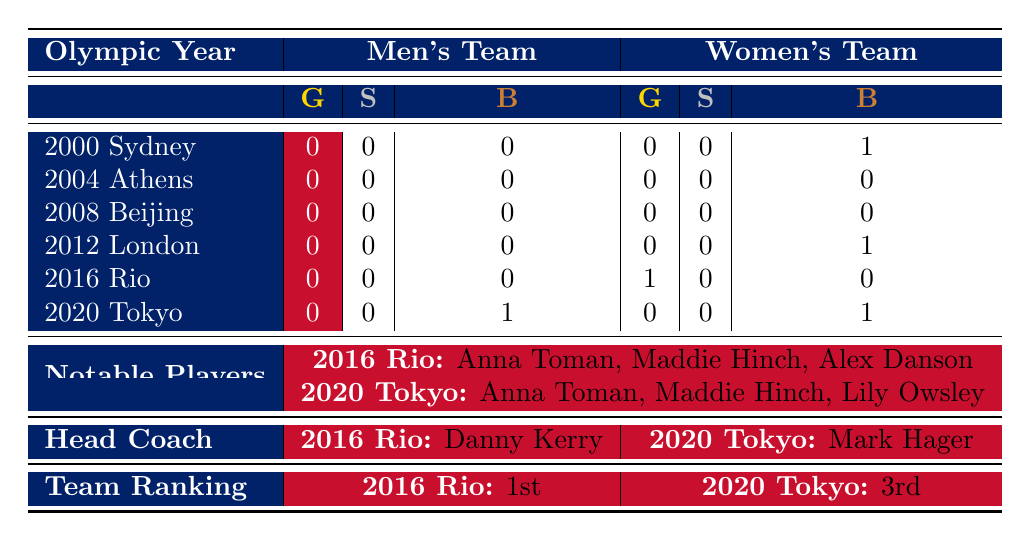What is the total number of medals won by the men's team in the 2020 Tokyo Olympics? The table shows that the men's team won 0 gold, 0 silver, and 1 bronze in the 2020 Tokyo Olympics. Therefore, the total number of medals is 0 + 0 + 1 = 1.
Answer: 1 How many medals did the women's team win in the 2016 Rio Olympics? The table indicates that the women's team won 1 gold, 0 silver, and 0 bronze medals in 2016. Thus, the total number of medals won is 1 + 0 + 0 = 1.
Answer: 1 Did the British men's field hockey team win any medals in the 2012 London Olympics? The table shows that the men's team won 0 gold, 0 silver, and 0 bronze in 2012. Therefore, they did not win any medals that year.
Answer: No What is the difference in total medal counts between the men's and women's teams in the 2020 Tokyo Olympics? For the men's team in 2020 Tokyo, there were 0 gold, 0 silver, and 1 bronze, totaling 1 medal. For the women's team, there were 0 gold, 0 silver, and 1 bronze, also totaling 1 medal. The difference is 1 - 1 = 0.
Answer: 0 Which year did the women's team achieve the highest medal count? Looking at the women's team data, they won medals in 2000 (1 bronze), 2012 (1 bronze), and 2016 (1 gold). In 2016, they won the only gold, indicating that it is the highest medal count for that team.
Answer: 2016 In which Olympics did Anna Toman play for the British women's team? Referring to the notable players listed, Anna Toman played in both the 2016 Rio Olympics and the 2020 Tokyo Olympics.
Answer: 2016 and 2020 How many bronze medals did the women's team win across all Olympic years listed? The table shows that the women's team won 1 bronze in Sydney (2000), 1 bronze in London (2012), and 1 bronze in Tokyo (2020). Summing these gives 1 + 1 + 1 = 3 bronze medals in total.
Answer: 3 Was there a year in which both teams won medals at the same Olympics? According to the table, there were no years where both teams won medals simultaneously. The only years with medals for women (2000, 2012, 2016, 2020) did not coincide with any men's medals.
Answer: No 